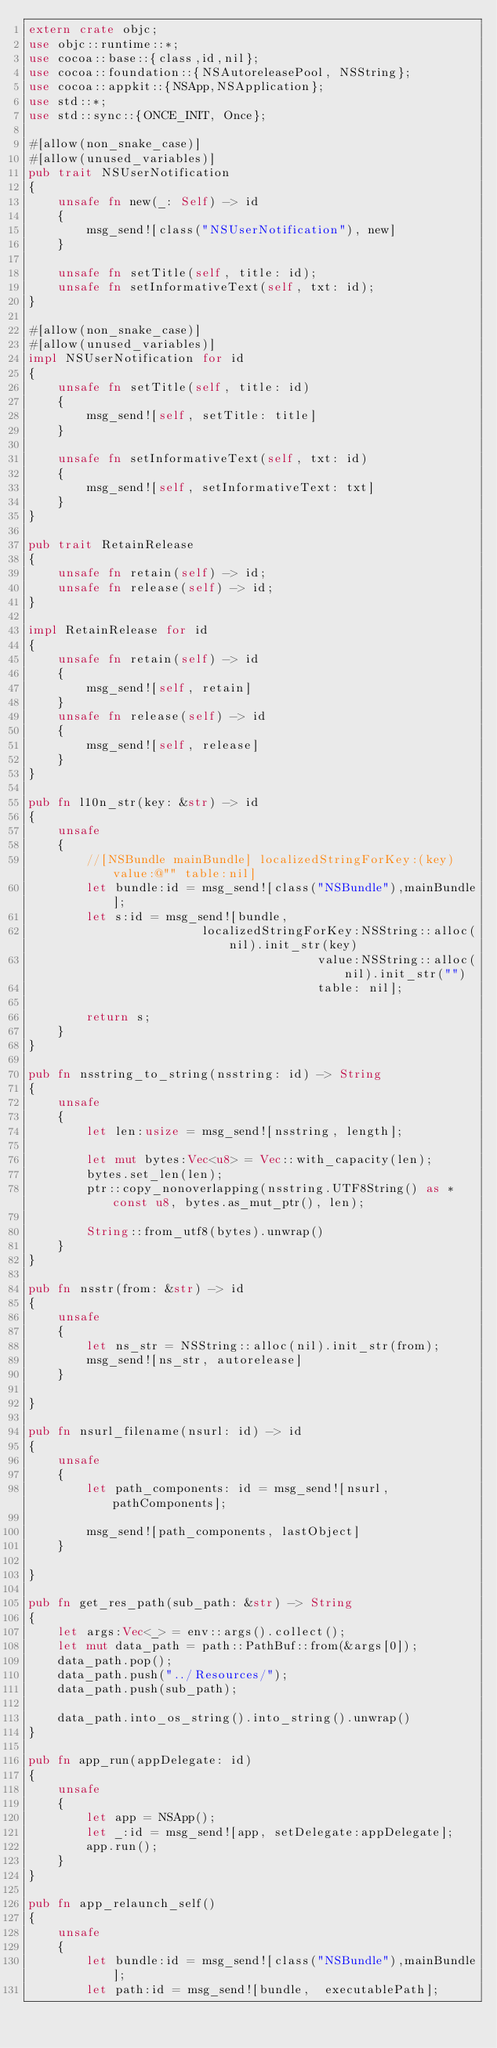Convert code to text. <code><loc_0><loc_0><loc_500><loc_500><_Rust_>extern crate objc;
use objc::runtime::*;
use cocoa::base::{class,id,nil};
use cocoa::foundation::{NSAutoreleasePool, NSString};
use cocoa::appkit::{NSApp,NSApplication};
use std::*;
use std::sync::{ONCE_INIT, Once};

#[allow(non_snake_case)]
#[allow(unused_variables)]
pub trait NSUserNotification
{
	unsafe fn new(_: Self) -> id
	{
		msg_send![class("NSUserNotification"), new]
	}

	unsafe fn setTitle(self, title: id);
	unsafe fn setInformativeText(self, txt: id);
}

#[allow(non_snake_case)]
#[allow(unused_variables)]
impl NSUserNotification for id
{
	unsafe fn setTitle(self, title: id)
	{
		msg_send![self, setTitle: title]
	}

	unsafe fn setInformativeText(self, txt: id)
	{
		msg_send![self, setInformativeText: txt]
	}
}

pub trait RetainRelease
{
	unsafe fn retain(self) -> id;
	unsafe fn release(self) -> id;
}

impl RetainRelease for id
{
	unsafe fn retain(self) -> id
	{
		msg_send![self, retain]
	}
	unsafe fn release(self) -> id
	{
		msg_send![self, release]
	}
}

pub fn l10n_str(key: &str) -> id
{
	unsafe
	{
		//[NSBundle mainBundle] localizedStringForKey:(key) value:@"" table:nil]
		let bundle:id = msg_send![class("NSBundle"),mainBundle];
		let s:id = msg_send![bundle, 
						localizedStringForKey:NSString::alloc(nil).init_str(key) 
										value:NSString::alloc(nil).init_str("") 
										table: nil];

		return s;
	}
}

pub fn nsstring_to_string(nsstring: id) -> String 
{
	unsafe
	{
		let len:usize = msg_send![nsstring, length];

		let mut bytes:Vec<u8> = Vec::with_capacity(len);
		bytes.set_len(len);
		ptr::copy_nonoverlapping(nsstring.UTF8String() as *const u8, bytes.as_mut_ptr(), len);
		
		String::from_utf8(bytes).unwrap()
	}
}

pub fn nsstr(from: &str) -> id 
{
	unsafe
	{
		let ns_str = NSString::alloc(nil).init_str(from);
		msg_send![ns_str, autorelease]
	}

}

pub fn nsurl_filename(nsurl: id) -> id
{
	unsafe
	{
		let path_components: id = msg_send![nsurl, pathComponents];
			
		msg_send![path_components, lastObject]
	}

}

pub fn get_res_path(sub_path: &str) -> String
{
	let args:Vec<_> = env::args().collect();
	let mut data_path = path::PathBuf::from(&args[0]);
	data_path.pop();
	data_path.push("../Resources/");
	data_path.push(sub_path);

	data_path.into_os_string().into_string().unwrap()
}

pub fn app_run(appDelegate: id)
{
	unsafe
	{
		let app = NSApp();
		let _:id = msg_send![app, setDelegate:appDelegate];
		app.run();
	}
}

pub fn app_relaunch_self()
{
	unsafe
	{
		let bundle:id = msg_send![class("NSBundle"),mainBundle];
		let path:id = msg_send![bundle,  executablePath];
</code> 